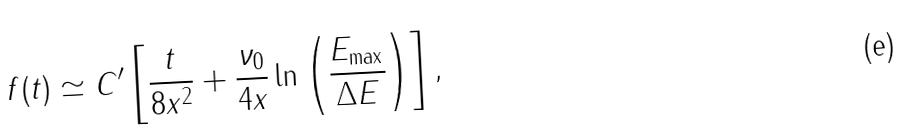<formula> <loc_0><loc_0><loc_500><loc_500>f ( t ) \simeq C ^ { \prime } \left [ \frac { t } { 8 x ^ { 2 } } + \frac { \nu _ { 0 } } { 4 x } \ln \left ( \frac { E _ { \max } } { \Delta E } \right ) \right ] ,</formula> 